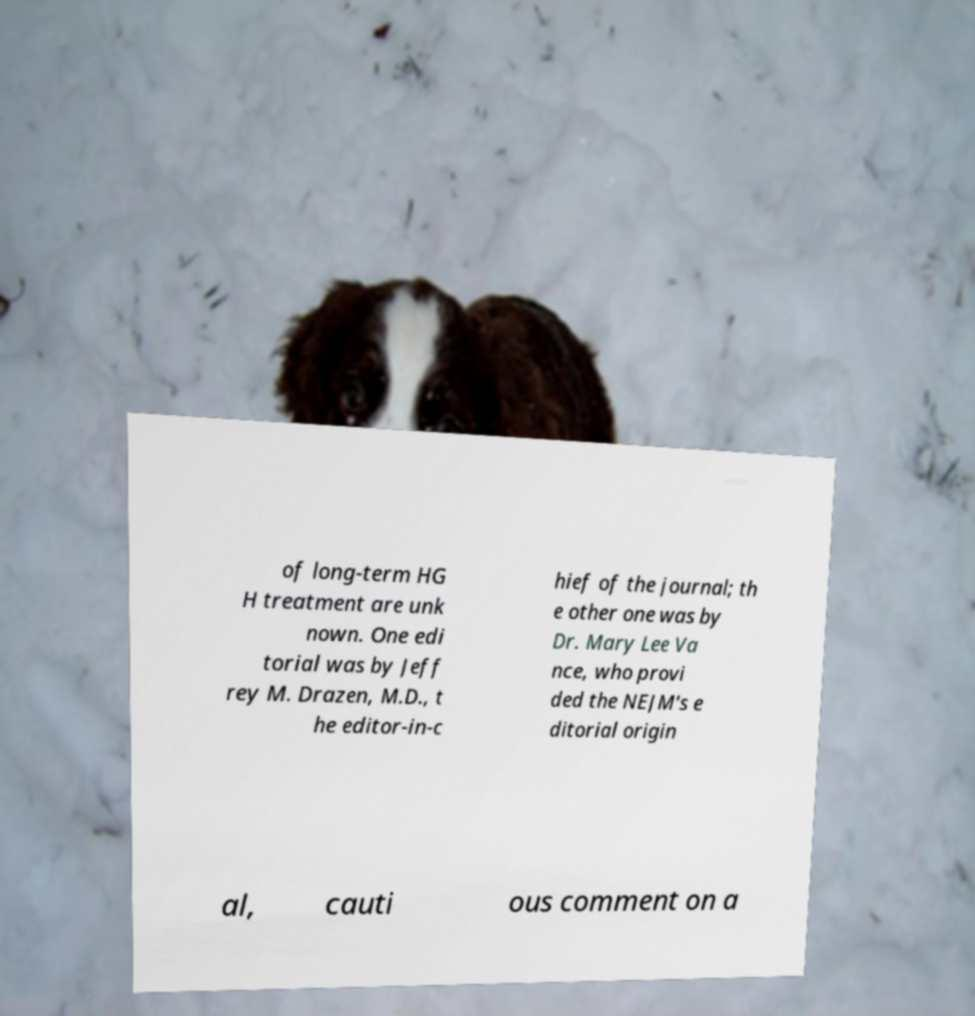There's text embedded in this image that I need extracted. Can you transcribe it verbatim? of long-term HG H treatment are unk nown. One edi torial was by Jeff rey M. Drazen, M.D., t he editor-in-c hief of the journal; th e other one was by Dr. Mary Lee Va nce, who provi ded the NEJM's e ditorial origin al, cauti ous comment on a 